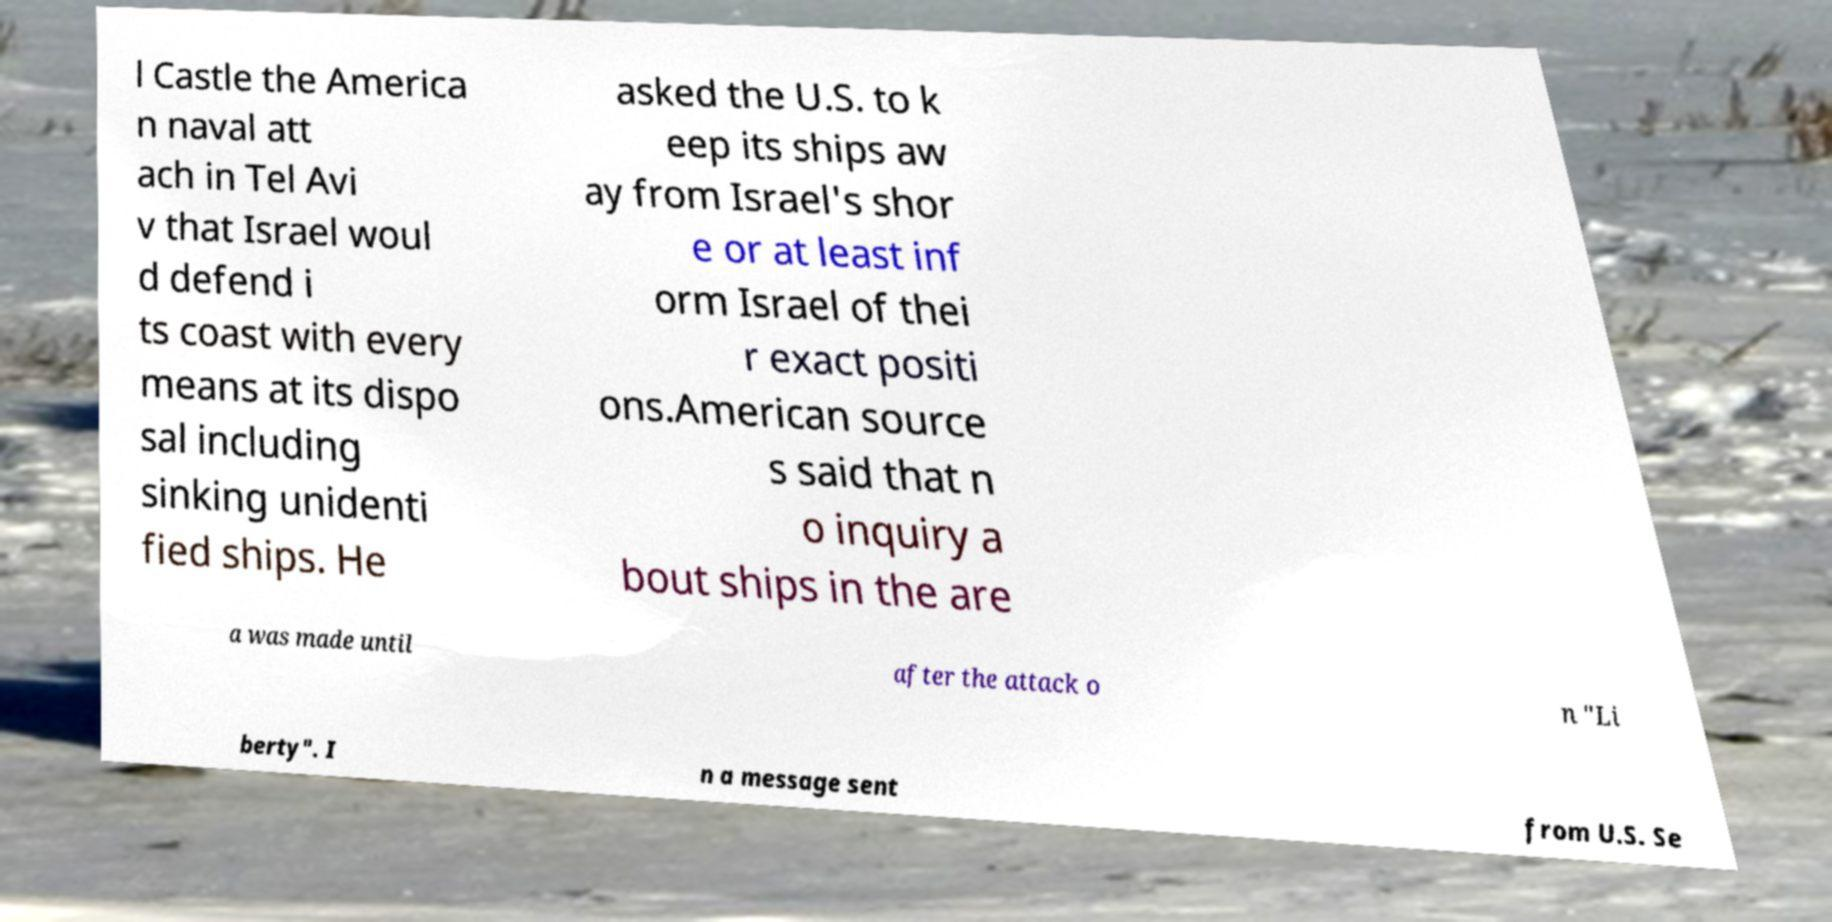Could you extract and type out the text from this image? l Castle the America n naval att ach in Tel Avi v that Israel woul d defend i ts coast with every means at its dispo sal including sinking unidenti fied ships. He asked the U.S. to k eep its ships aw ay from Israel's shor e or at least inf orm Israel of thei r exact positi ons.American source s said that n o inquiry a bout ships in the are a was made until after the attack o n "Li berty". I n a message sent from U.S. Se 